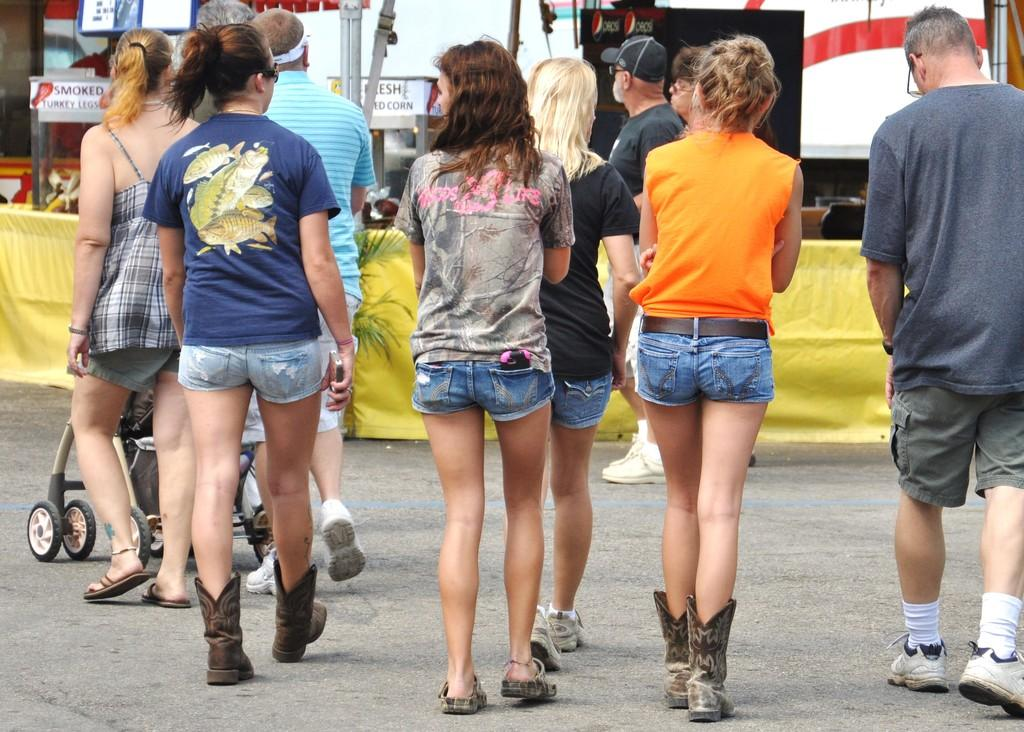Who or what can be seen in the image? There are people in the image. What are the people doing in the image? The people are walking on a road. What type of lace can be seen on the house in the image? There is no house or lace present in the image; it only features people walking on a road. 